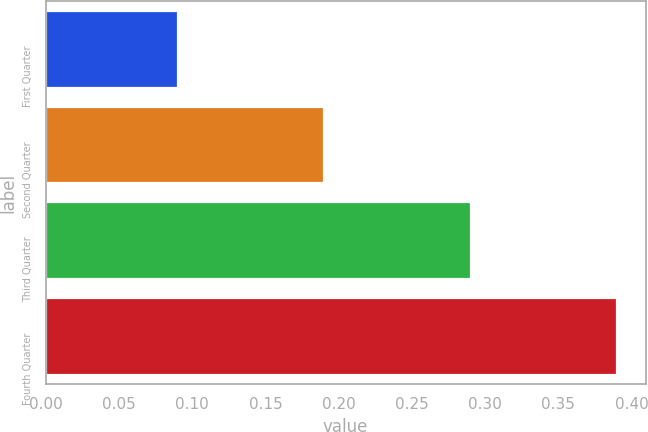Convert chart. <chart><loc_0><loc_0><loc_500><loc_500><bar_chart><fcel>First Quarter<fcel>Second Quarter<fcel>Third Quarter<fcel>Fourth Quarter<nl><fcel>0.09<fcel>0.19<fcel>0.29<fcel>0.39<nl></chart> 